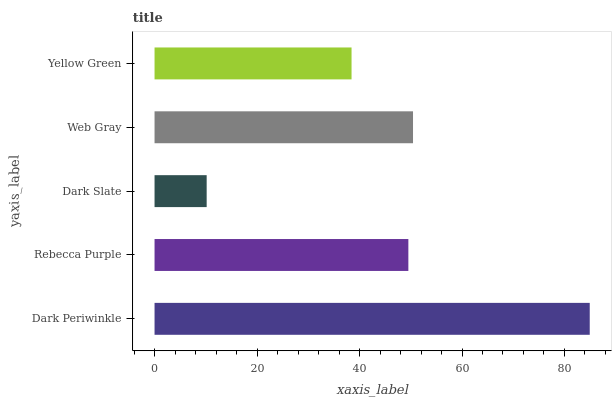Is Dark Slate the minimum?
Answer yes or no. Yes. Is Dark Periwinkle the maximum?
Answer yes or no. Yes. Is Rebecca Purple the minimum?
Answer yes or no. No. Is Rebecca Purple the maximum?
Answer yes or no. No. Is Dark Periwinkle greater than Rebecca Purple?
Answer yes or no. Yes. Is Rebecca Purple less than Dark Periwinkle?
Answer yes or no. Yes. Is Rebecca Purple greater than Dark Periwinkle?
Answer yes or no. No. Is Dark Periwinkle less than Rebecca Purple?
Answer yes or no. No. Is Rebecca Purple the high median?
Answer yes or no. Yes. Is Rebecca Purple the low median?
Answer yes or no. Yes. Is Yellow Green the high median?
Answer yes or no. No. Is Yellow Green the low median?
Answer yes or no. No. 